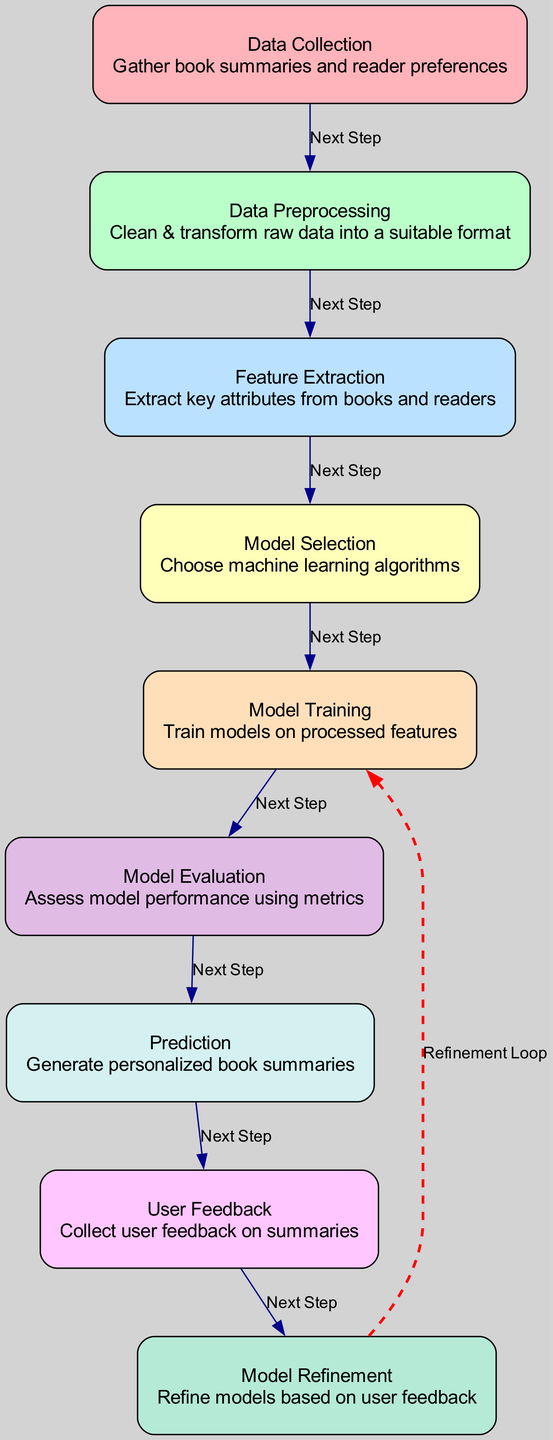What is the total number of nodes in the diagram? The diagram contains a list of nodes, which includes Data Collection, Data Preprocessing, Feature Extraction, Model Selection, Training, Evaluation, Prediction, User Feedback, and Model Refinement. Counting these, there are nine nodes in total.
Answer: 9 Which node comes after Data Preprocessing? From the diagram's flow, after Data Preprocessing, the next step is Feature Extraction, as indicated by the directed edge.
Answer: Feature Extraction How many edges are labeled 'Next Step'? Each edge is labeled either 'Next Step' or 'Refinement Loop'. There are seven edges labeled 'Next Step', indicated by the connections made in a linear fashion from data collection to prediction.
Answer: 7 Which node leads to Model Refinement? Following the flow of the diagram, the node leading to Model Refinement is User Feedback, which suggests that feedback is a critical part before refining the model.
Answer: User Feedback What type of loop is indicated in the diagram? The diagram displays a 'Refinement Loop', which is a distinct connection made from Model Refinement back to Training, showing the iterative nature of the model improvement process.
Answer: Refinement Loop What is the purpose of Model Evaluation in the process? Model Evaluation serves to assess the performance of the machine learning model using various metrics after the training stage. This is crucial for understanding how well the model can perform predictions.
Answer: Assess performance Which node is responsible for generating personalized book summaries? According to the flow of the diagram, the Prediction node is specifically tasked with generating personalized book summaries based on the trained model's predictions.
Answer: Prediction What step comes directly after Model Training? Model Training is followed directly by Model Evaluation in the process, ensuring that the trained models are effectively assessed for their performance before making predictions.
Answer: Model Evaluation How does User Feedback influence the machine learning process? User Feedback collected after the prediction stage is foundational for the Model Refinement process, as it enables adjustments and improvements to the models based on user experiences and suggestions.
Answer: Refine models 